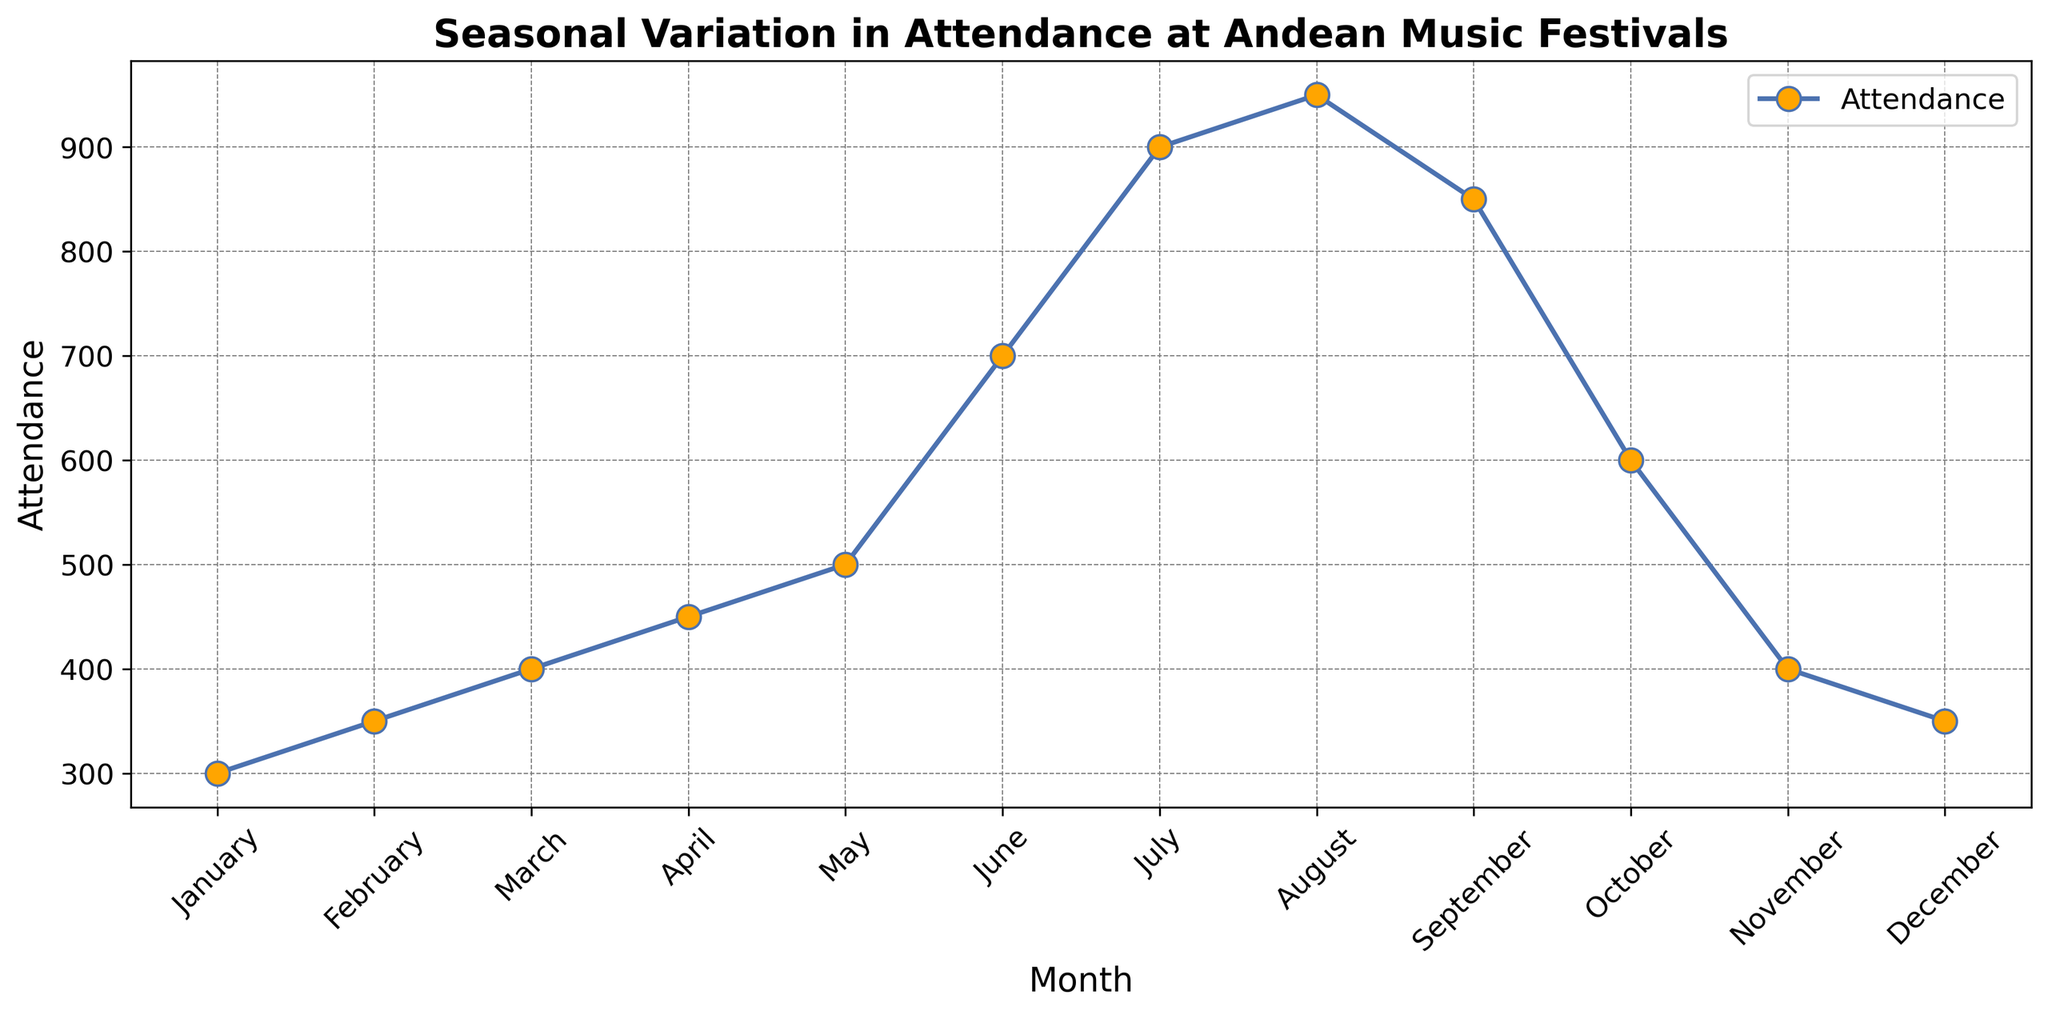What's the month with the highest attendance? By looking at the peak point in the plot, we can identify the month with the highest attendance. The highest point occurs in August.
Answer: August What's the month with the lowest attendance? By identifying the lowest point on the plot, we can determine that January has the lowest attendance.
Answer: January What’s the difference in attendance between the highest and lowest month? Referencing the data points for the highest and lowest months, August (950) and January (300) respectively. Calculating the difference, 950 - 300 = 650.
Answer: 650 How does the attendance in July compare to that in January? July’s attendance is 900, while January’s is 300. Since 900 is greater than 300, attendance in July is significantly higher than in January.
Answer: July has higher attendance Which months have an attendance greater than 600? Referring to the y-axis and 'Month' labels, the months exceeding 600 in attendance are June, July, August, and September.
Answer: June, July, August, September What’s the average attendance over the summer months (June, July, August)? Summing attendances of June (700), July (900), and August (950) gives 700 + 900 + 950 = 2550, then dividing by 3 (number of months), 2550 / 3 = 850.
Answer: 850 Which month sees a sharp decline in attendance from the previous month? Observing the plot trend, from September to October, there’s a significant drop from 850 to 600.
Answer: October How does the visual marker (color and shape) for attendance data points look? Each attendance data point is marked with a blue line connected by orange-filled circles.
Answer: Blue line with orange circles What’s the total attendance for the first three months of the year? Summing attendance for January (300), February (350), and March (400) gives 300 + 350 + 400 = 1050.
Answer: 1050 Does attendance tend to increase or decrease towards the middle of the year? Observing the trend from January to August, attendance increases consistently towards the middle of the year.
Answer: Increase 